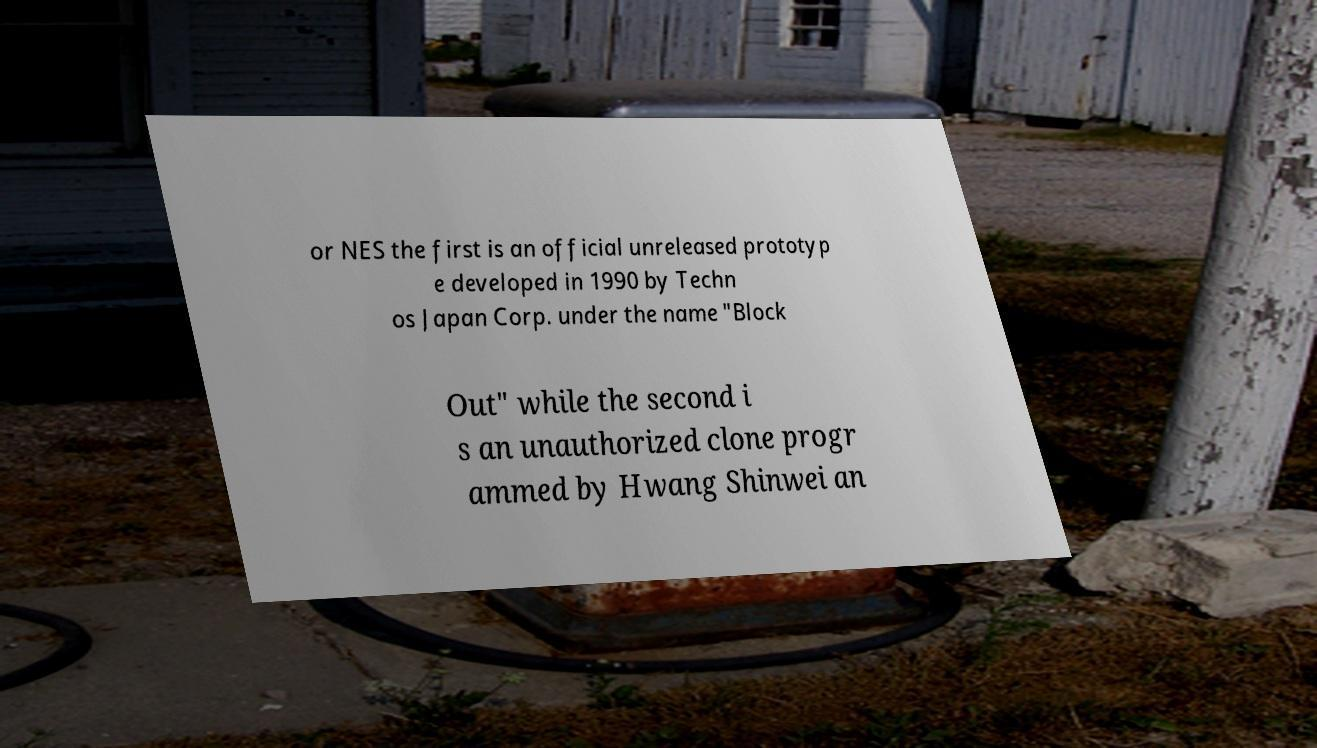Could you extract and type out the text from this image? or NES the first is an official unreleased prototyp e developed in 1990 by Techn os Japan Corp. under the name "Block Out" while the second i s an unauthorized clone progr ammed by Hwang Shinwei an 